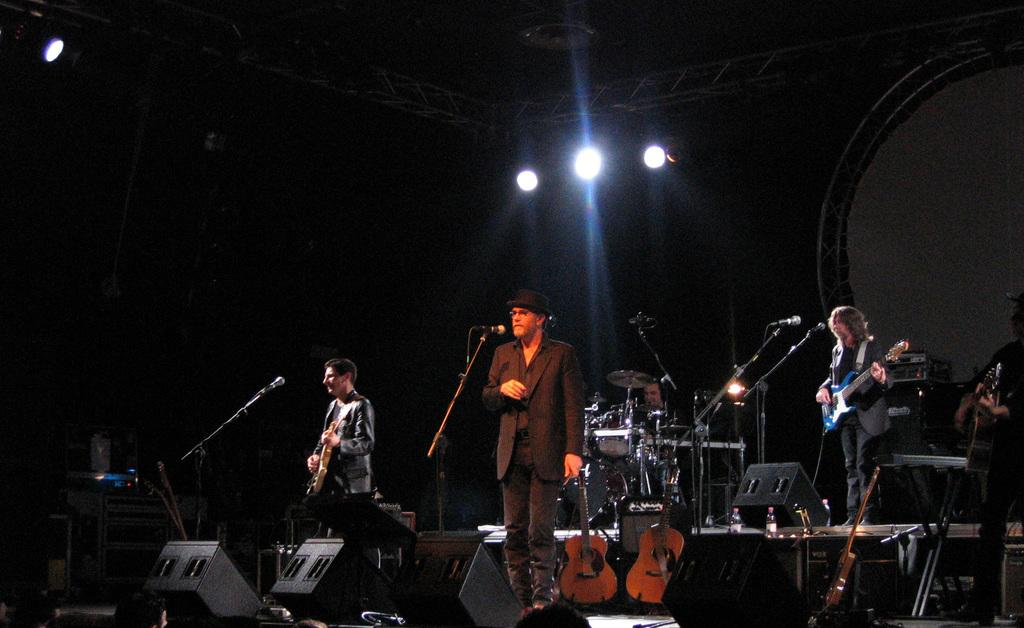What are the people in the image doing? The people in the image are standing with microphones in front of them. What instrument is being played by one of the people in the image? There is a person playing the guitar in the image. What type of eggnog can be seen in the background of the image? There is no eggnog present in the image. Can you tell me how many mountains are visible in the image? There are no mountains visible in the image. 